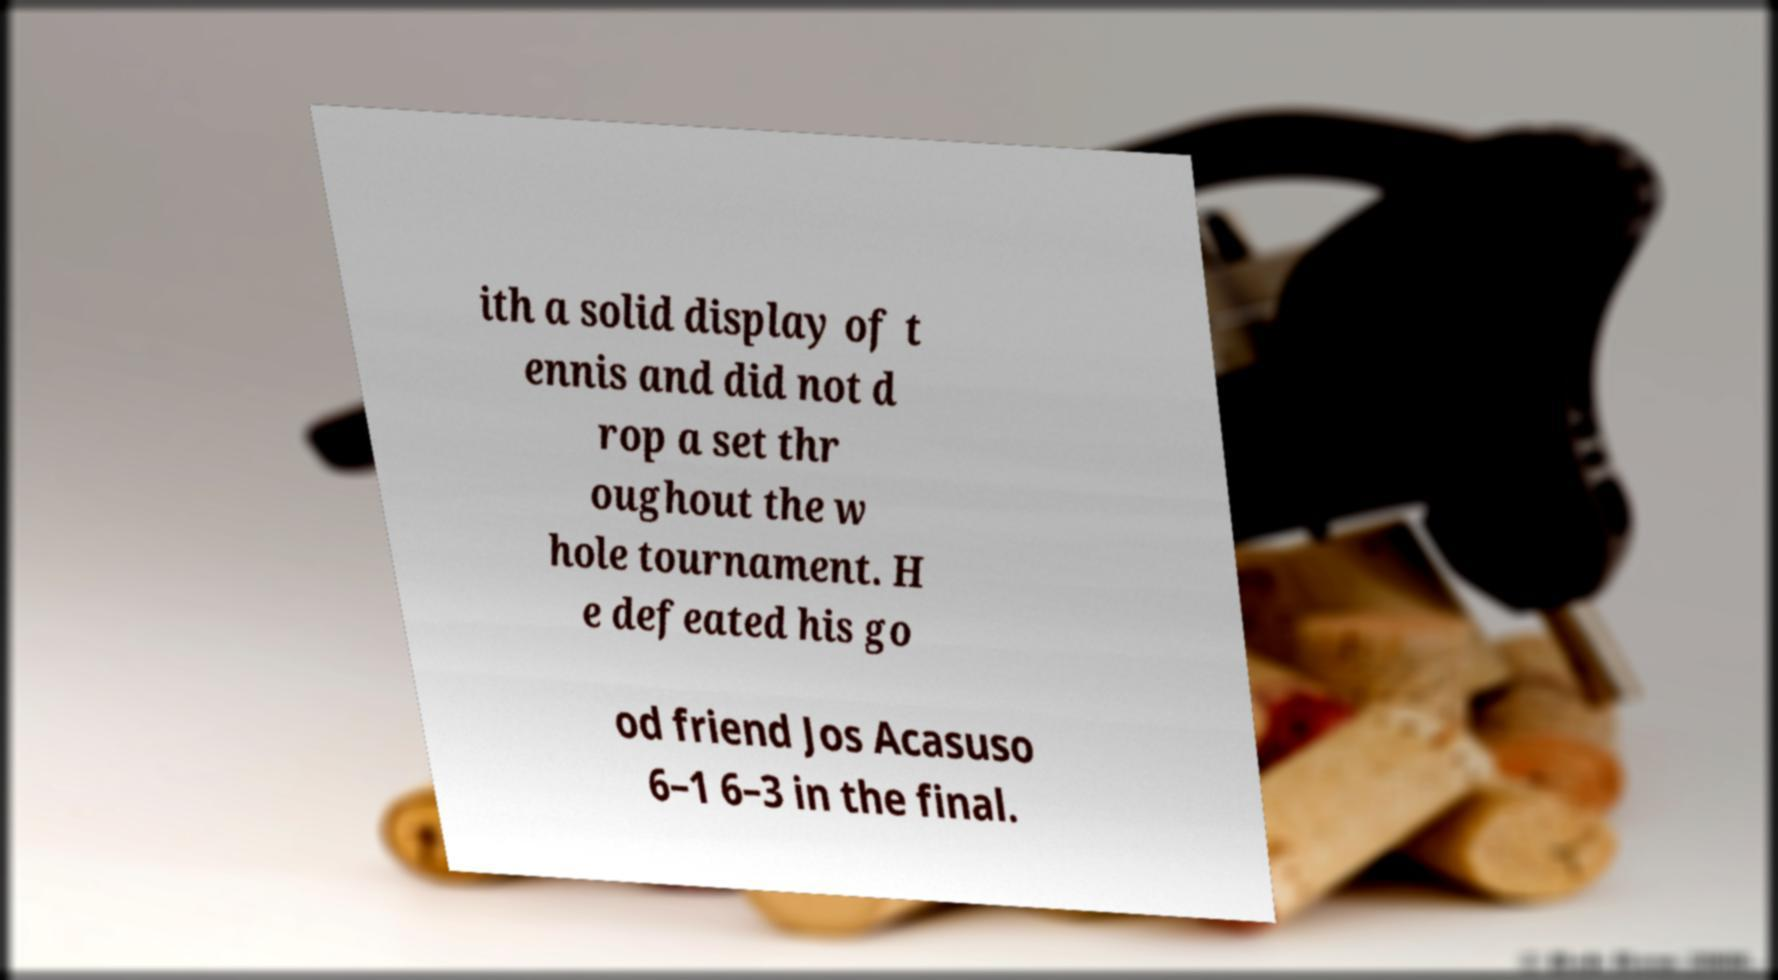Can you read and provide the text displayed in the image?This photo seems to have some interesting text. Can you extract and type it out for me? ith a solid display of t ennis and did not d rop a set thr oughout the w hole tournament. H e defeated his go od friend Jos Acasuso 6–1 6–3 in the final. 